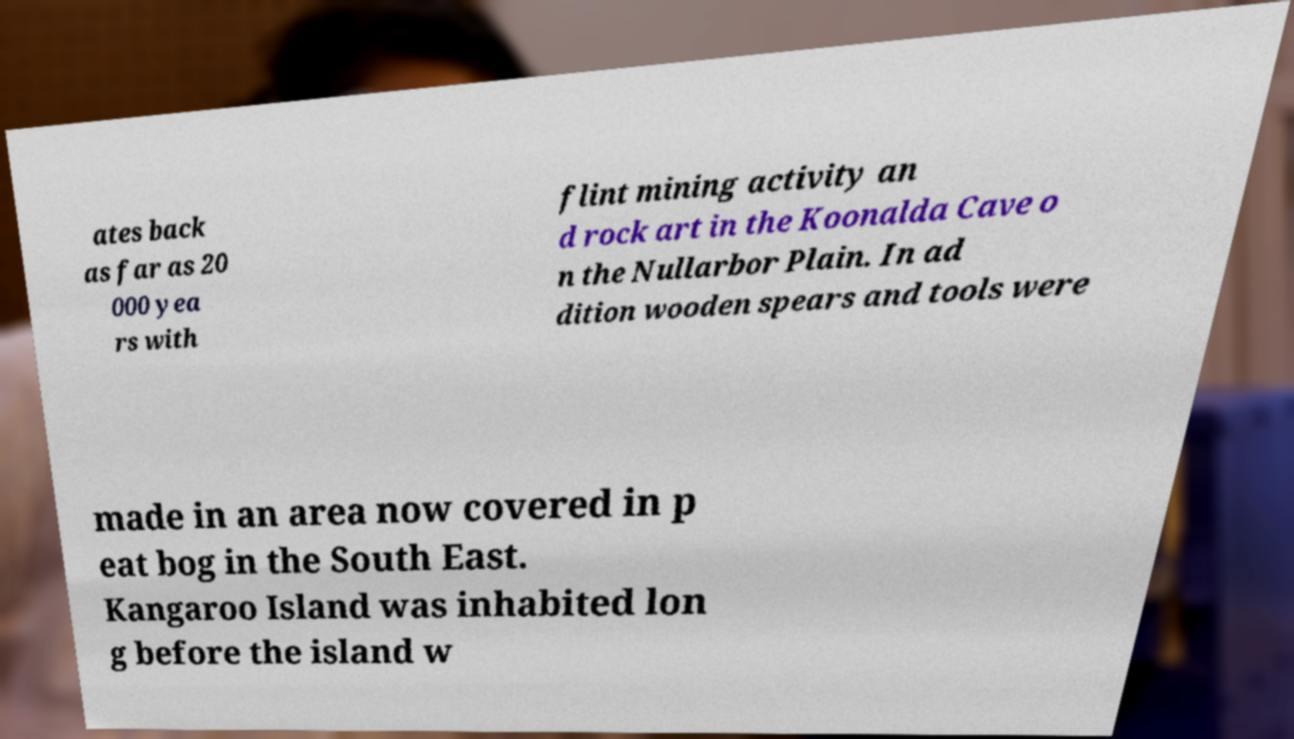What messages or text are displayed in this image? I need them in a readable, typed format. ates back as far as 20 000 yea rs with flint mining activity an d rock art in the Koonalda Cave o n the Nullarbor Plain. In ad dition wooden spears and tools were made in an area now covered in p eat bog in the South East. Kangaroo Island was inhabited lon g before the island w 